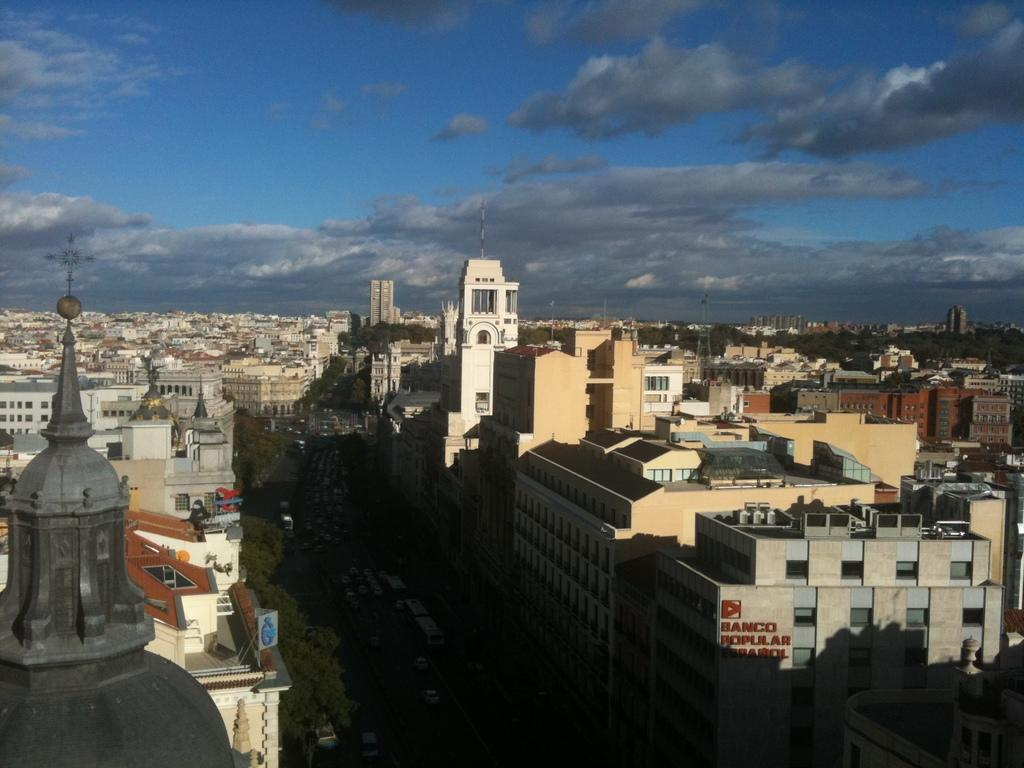What type of structures can be seen in the image? There are buildings in the image. What part of the natural environment is visible in the image? The sky is visible in the image. How many boys are present in the image? There is no boy present in the image; it only features buildings and the sky. What type of chickens can be seen in the image? There are no chickens present in the image; it only features buildings and the sky. 